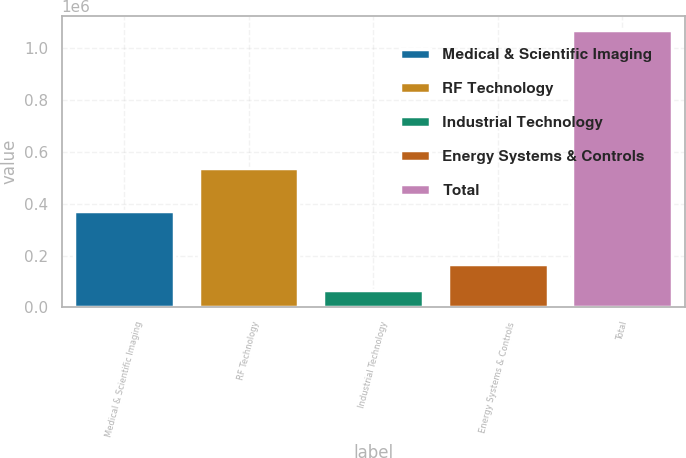Convert chart to OTSL. <chart><loc_0><loc_0><loc_500><loc_500><bar_chart><fcel>Medical & Scientific Imaging<fcel>RF Technology<fcel>Industrial Technology<fcel>Energy Systems & Controls<fcel>Total<nl><fcel>373213<fcel>538877<fcel>68002<fcel>168248<fcel>1.07046e+06<nl></chart> 